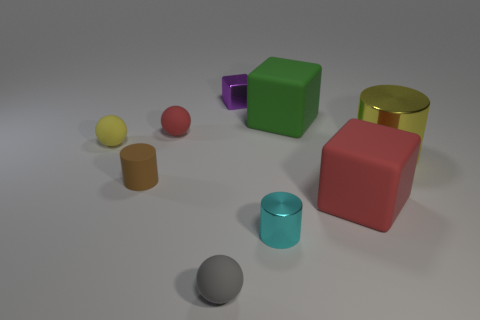Is there any other thing of the same color as the small cube?
Offer a very short reply. No. Is there anything else that is the same size as the cyan thing?
Ensure brevity in your answer.  Yes. How many things are small yellow things or green blocks?
Offer a terse response. 2. Are there any red things of the same size as the red rubber sphere?
Offer a very short reply. No. What shape is the gray rubber object?
Your answer should be compact. Sphere. Are there more metallic cylinders in front of the small cyan object than cyan metal cylinders that are in front of the gray sphere?
Your answer should be very brief. No. There is a rubber object that is in front of the cyan object; is it the same color as the shiny object right of the tiny cyan metal object?
Offer a terse response. No. The green rubber thing that is the same size as the yellow shiny cylinder is what shape?
Give a very brief answer. Cube. Are there any other things that have the same shape as the small yellow thing?
Provide a succinct answer. Yes. Do the large block that is behind the tiny yellow rubber object and the large cube that is in front of the yellow metal cylinder have the same material?
Keep it short and to the point. Yes. 